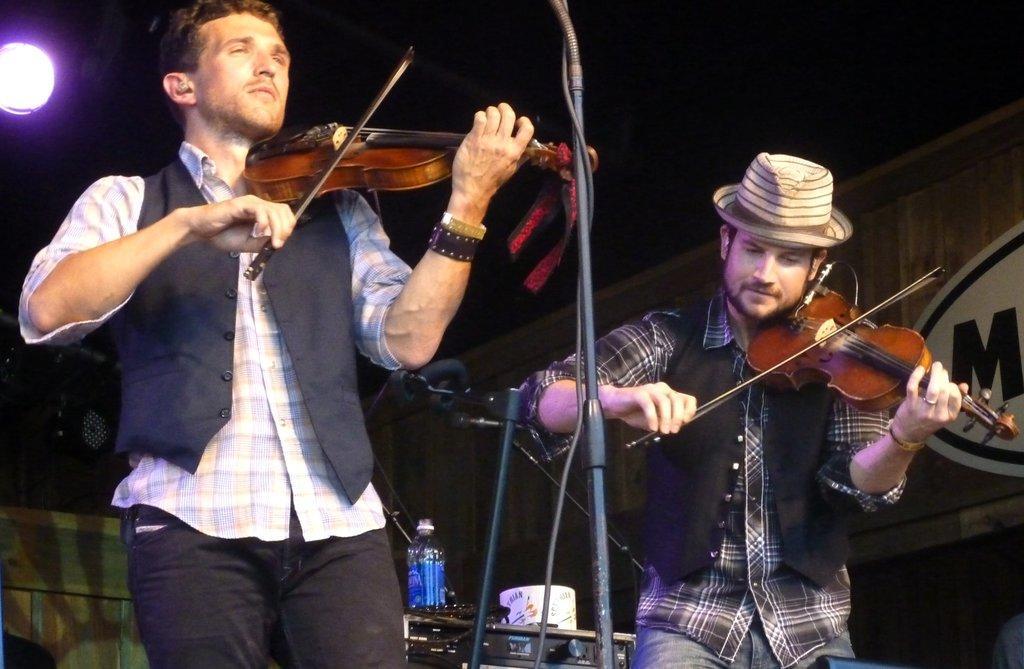How would you summarize this image in a sentence or two? This image is clicked in a musical concert. There are two persons in this image. Both of them are holding violins. There are lights on the top. There are mikes in the middle. Behind them there is a water bottle. 